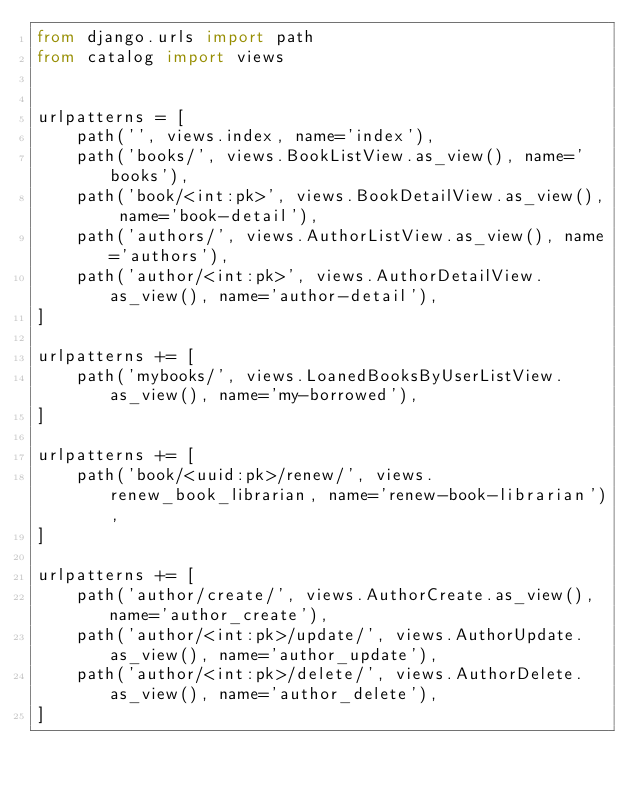Convert code to text. <code><loc_0><loc_0><loc_500><loc_500><_Python_>from django.urls import path
from catalog import views


urlpatterns = [
    path('', views.index, name='index'),
    path('books/', views.BookListView.as_view(), name='books'),
    path('book/<int:pk>', views.BookDetailView.as_view(), name='book-detail'),
    path('authors/', views.AuthorListView.as_view(), name='authors'),
    path('author/<int:pk>', views.AuthorDetailView.as_view(), name='author-detail'),
]

urlpatterns += [   
    path('mybooks/', views.LoanedBooksByUserListView.as_view(), name='my-borrowed'),
]

urlpatterns += [   
    path('book/<uuid:pk>/renew/', views.renew_book_librarian, name='renew-book-librarian'),
]

urlpatterns += [  
    path('author/create/', views.AuthorCreate.as_view(), name='author_create'),
    path('author/<int:pk>/update/', views.AuthorUpdate.as_view(), name='author_update'),
    path('author/<int:pk>/delete/', views.AuthorDelete.as_view(), name='author_delete'),
]</code> 